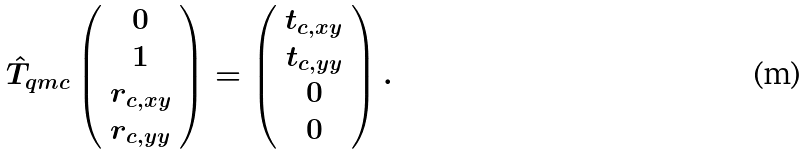Convert formula to latex. <formula><loc_0><loc_0><loc_500><loc_500>\hat { T } _ { q m c } \left ( \begin{array} { c } 0 \\ 1 \\ r _ { c , x y } \\ r _ { c , y y } \end{array} \right ) = \left ( \begin{array} { c } t _ { c , x y } \\ t _ { c , y y } \\ 0 \\ 0 \end{array} \right ) .</formula> 